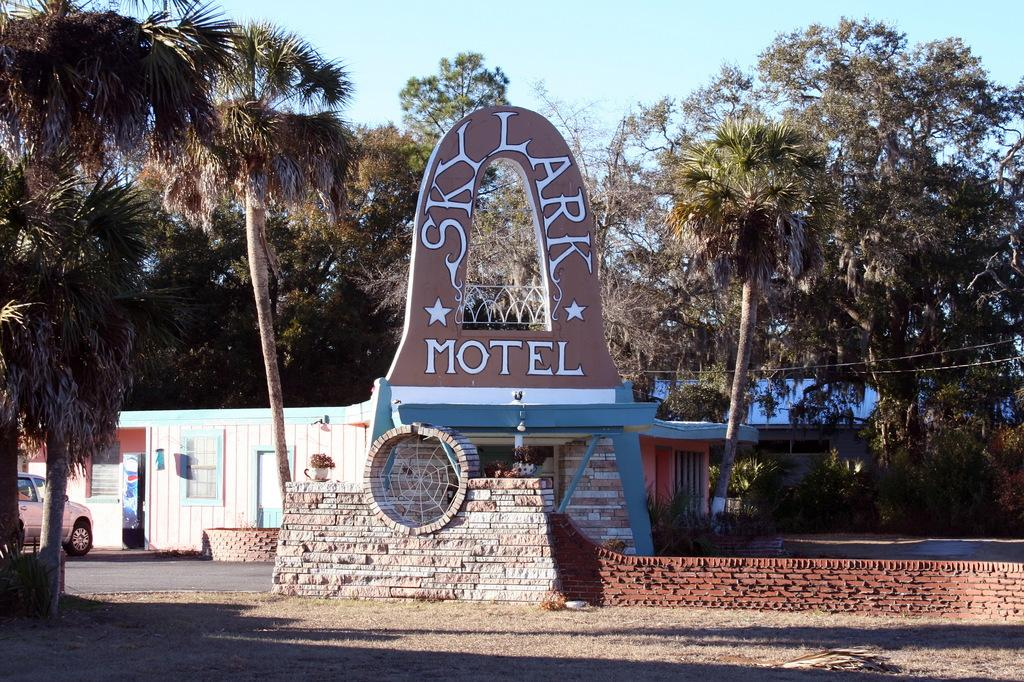What type of structure is visible in the image? There is a house in the image. What else can be seen on the house or near it? There is a poster with text on it, a vehicle, a stone wall, trees, and dry grass. Can you describe the poster in the image? The poster has text on it. What is visible in the sky in the image? The sky is visible in the image. How many balls are being juggled by the rat in the image? There is no rat or balls present in the image. 